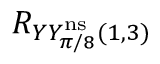<formula> <loc_0><loc_0><loc_500><loc_500>R _ { Y Y _ { \pi / 8 } ^ { n s } ( 1 , 3 ) }</formula> 